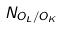<formula> <loc_0><loc_0><loc_500><loc_500>N _ { O _ { L } / O _ { K } }</formula> 